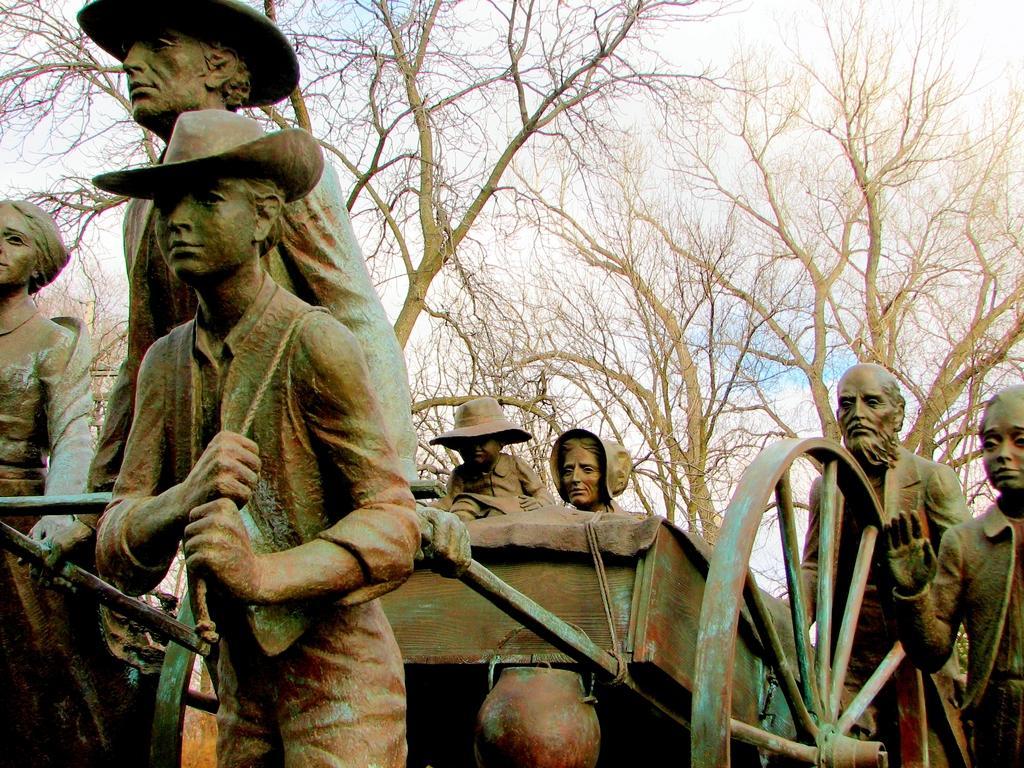Can you describe this image briefly? In this image, we can see some statues. There is a moving cart at the bottom of the image. In the background, we can see some trees. 